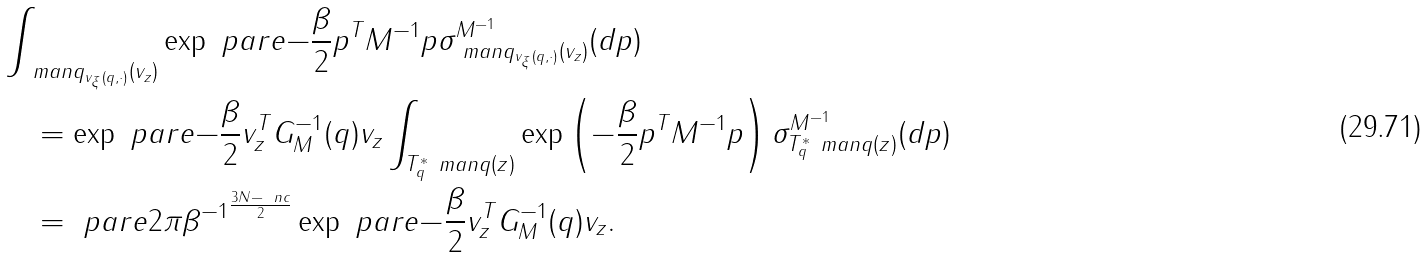Convert formula to latex. <formula><loc_0><loc_0><loc_500><loc_500>& \int _ { \ m a n q _ { v _ { \xi } ( q , \cdot ) } ( v _ { z } ) } \exp \ p a r e { - \frac { \beta } { 2 } p ^ { T } M ^ { - 1 } p } \sigma ^ { M ^ { - 1 } } _ { \ m a n q _ { v _ { \xi } ( q , \cdot ) } ( v _ { z } ) } ( d p ) \\ & \quad = \exp \ p a r e { - \frac { \beta } { 2 } v _ { z } ^ { T } G _ { M } ^ { - 1 } ( q ) v _ { z } } \int _ { T ^ { * } _ { q } \ m a n q ( z ) } \exp \left ( - \frac { \beta } { 2 } p ^ { T } M ^ { - 1 } p \right ) \sigma ^ { M ^ { - 1 } } _ { T ^ { * } _ { q } \ m a n q ( z ) } ( d p ) \\ & \quad = \ p a r e { 2 \pi \beta ^ { - 1 } } ^ { \frac { 3 N - \ n c } { 2 } } \exp \ p a r e { - \frac { \beta } { 2 } v _ { z } ^ { T } G _ { M } ^ { - 1 } ( q ) v _ { z } } .</formula> 